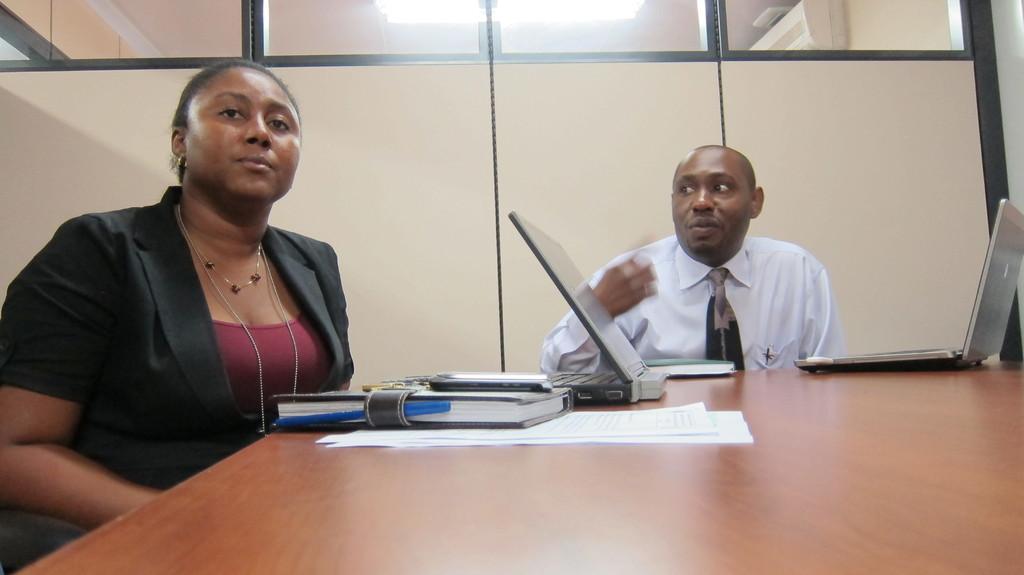Could you give a brief overview of what you see in this image? In the foreground of this image, on the table, there are books, laptops, few papers and a mobile phone. On the left, there is a woman sitting and behind the table, there is a man sitting. In the background, there is the wall and on the top, there is the light. 